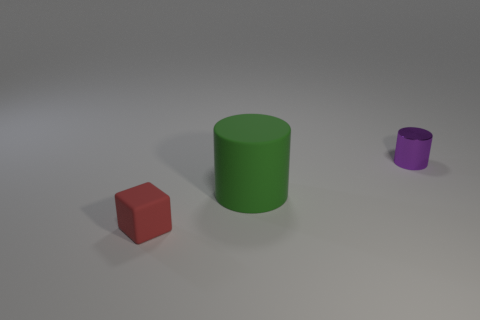Does the small object in front of the rubber cylinder have the same shape as the large rubber object?
Provide a short and direct response. No. Is the number of small rubber objects that are behind the purple object greater than the number of small yellow matte cylinders?
Your answer should be very brief. No. The cylinder that is the same size as the matte cube is what color?
Your answer should be compact. Purple. How many things are tiny things that are in front of the purple thing or big rubber cylinders?
Give a very brief answer. 2. What is the material of the small object behind the matte thing in front of the green thing?
Your response must be concise. Metal. Are there any blocks made of the same material as the red thing?
Give a very brief answer. No. There is a tiny thing on the left side of the purple cylinder; are there any metallic cylinders right of it?
Keep it short and to the point. Yes. What material is the small thing to the left of the small purple metallic cylinder?
Your response must be concise. Rubber. Do the large matte thing and the tiny purple shiny thing have the same shape?
Your response must be concise. Yes. There is a tiny object that is to the right of the tiny thing in front of the tiny object behind the tiny rubber block; what is its color?
Your answer should be compact. Purple. 